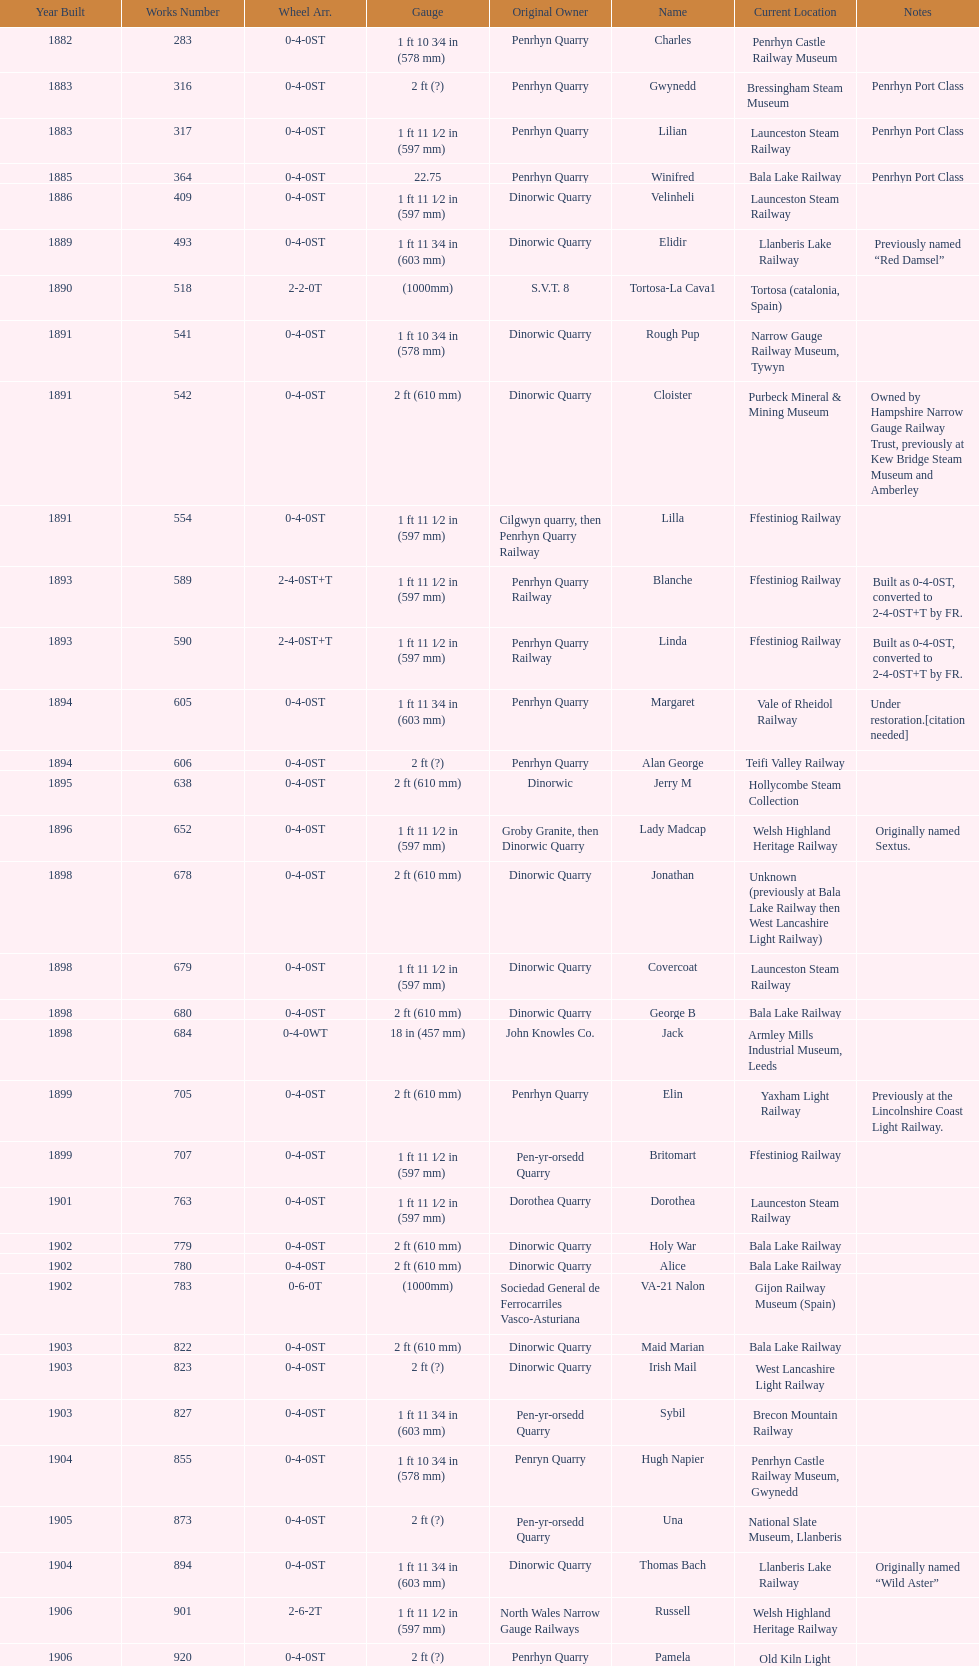When was the record year for the construction of steam locomotives? 1898. 